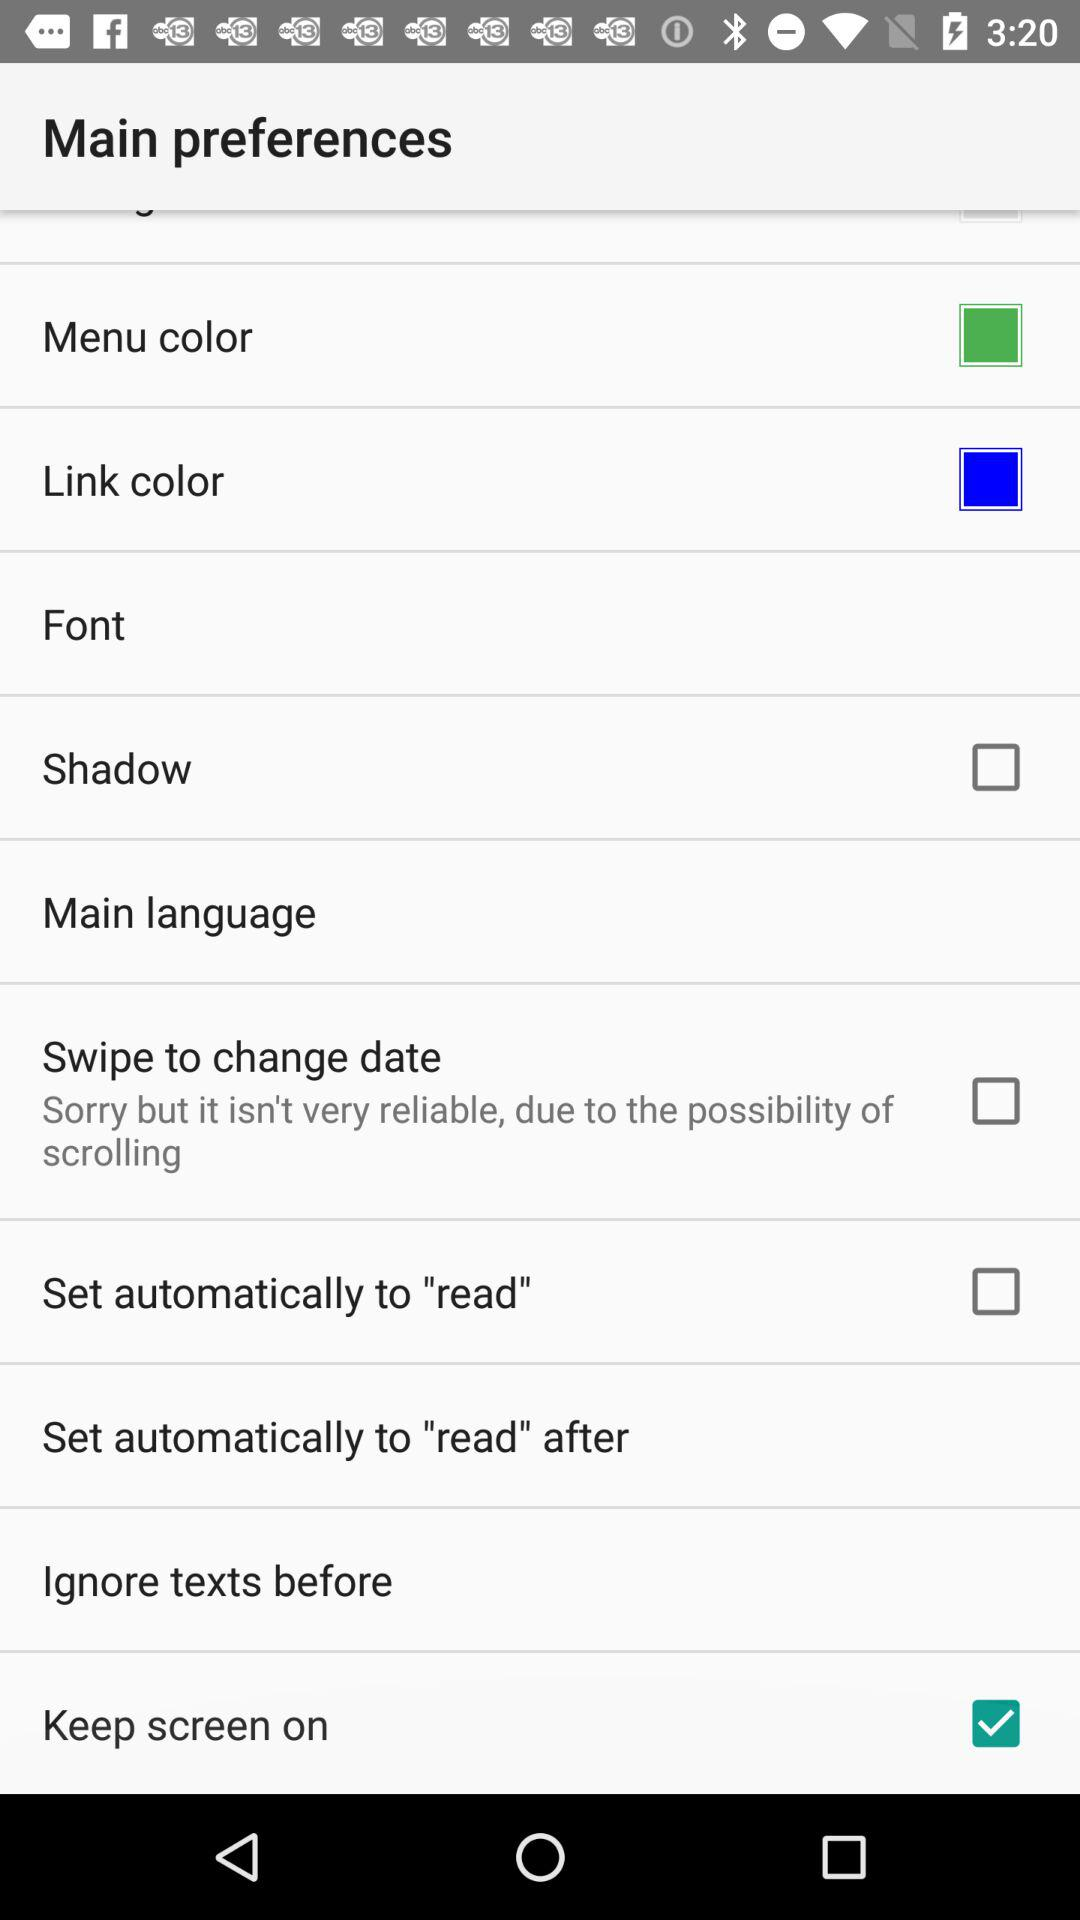What is the current status of "Shadow"? The current status is "off". 